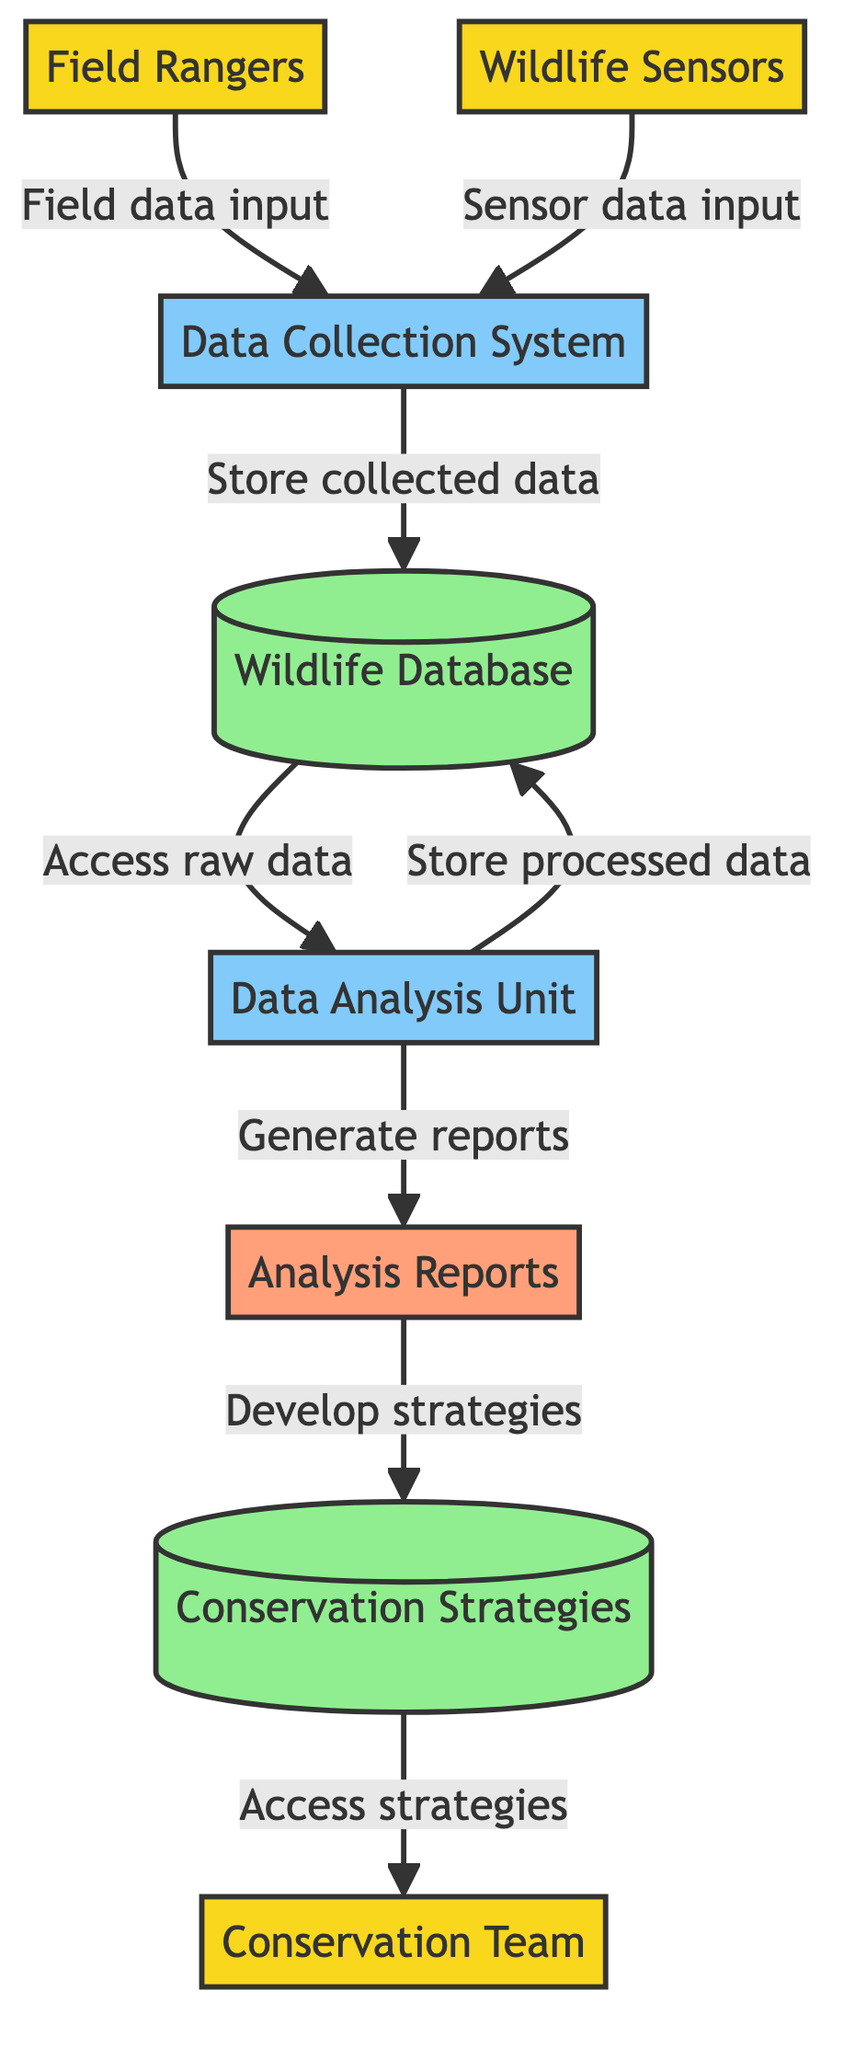What is the role of Field Rangers in the diagram? Field Rangers act as external entities that collect field data and observations which they input into the Data Collection System.
Answer: Data collector How many external entities are shown in the diagram? The diagram displays three external entities: Field Rangers, Wildlife Sensors, and Conservation Team.
Answer: Three What type of data store is the Wildlife Database? The Wildlife Database is classified as a datastore that stores both raw and processed wildlife data.
Answer: Datastore Which process generates the Analysis Reports? The Data Analysis Unit processes the collected data and generates the Analysis Reports.
Answer: Data Analysis Unit What does the Conservation Team access according to the flow? The Conservation Team accesses the Conservation Strategies developed from the Analysis Reports for implementation.
Answer: Conservation Strategies What is the relationship between the Data Collection System and the Wildlife Database? The Data Collection System stores collected data into the Wildlife Database and retrieves data from it for analysis.
Answer: Storage and retrieval What type of data flow occurs between Analysis Reports and Conservation Strategies? The flow between Analysis Reports and Conservation Strategies involves the storage of developed conservation strategies.
Answer: Storage How many processes are involved in this data flow diagram? The diagram includes two key processes: Data Collection System and Data Analysis Unit.
Answer: Two What do Wildlife Sensors contribute to the system? Wildlife Sensors provide sensor data input into the Data Collection System.
Answer: Sensor data input 